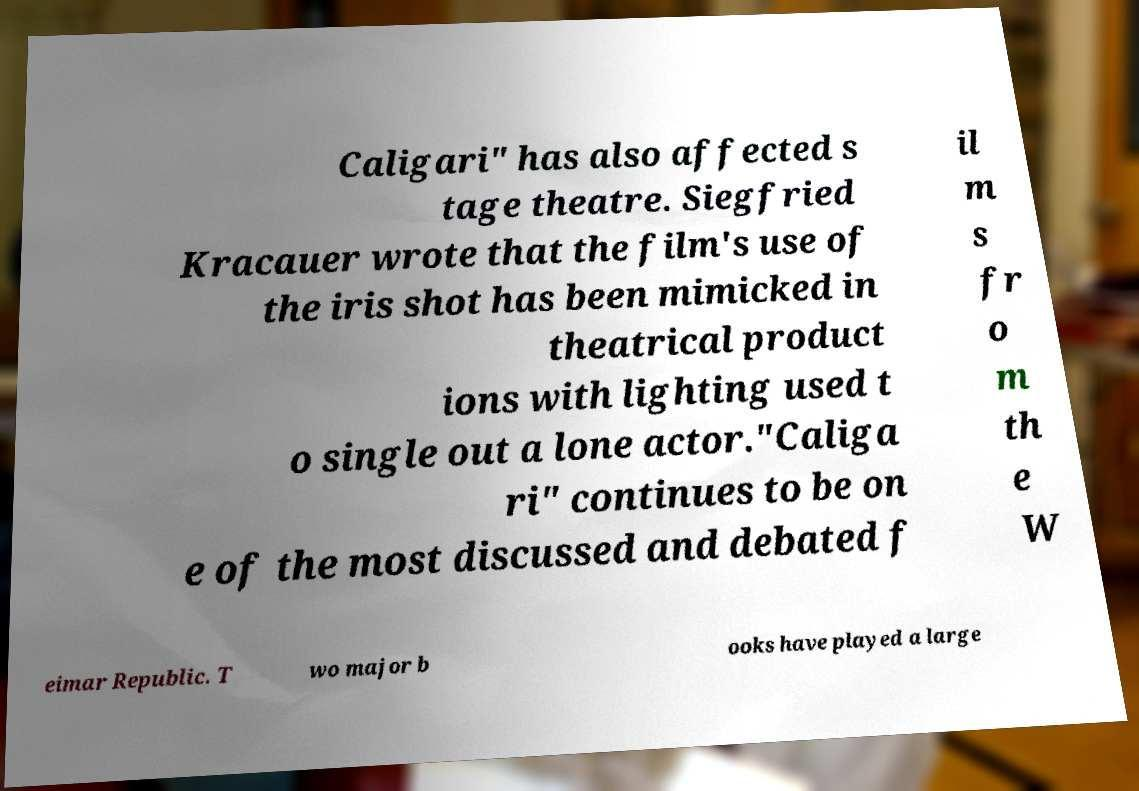Please identify and transcribe the text found in this image. Caligari" has also affected s tage theatre. Siegfried Kracauer wrote that the film's use of the iris shot has been mimicked in theatrical product ions with lighting used t o single out a lone actor."Caliga ri" continues to be on e of the most discussed and debated f il m s fr o m th e W eimar Republic. T wo major b ooks have played a large 